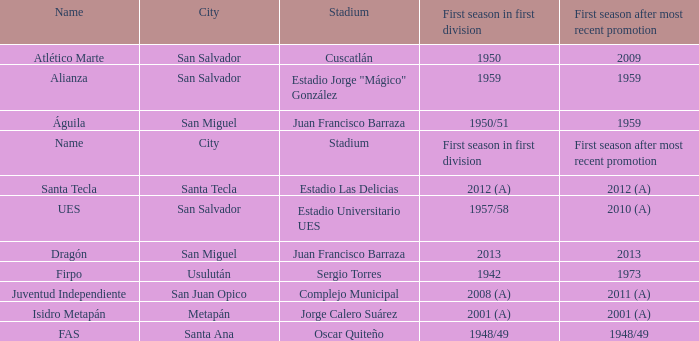Which city is Alianza? San Salvador. 